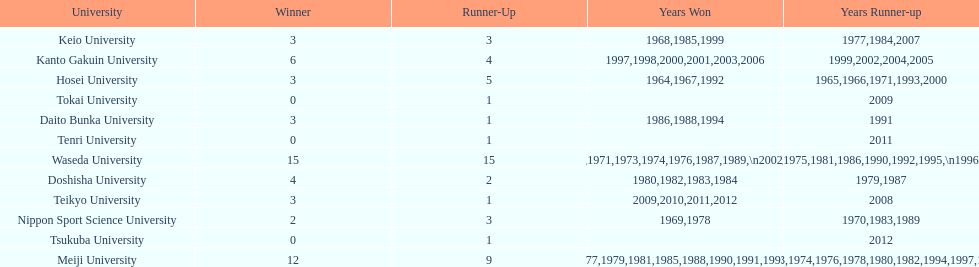Hosei won in 1964. who won the next year? Waseda University. 